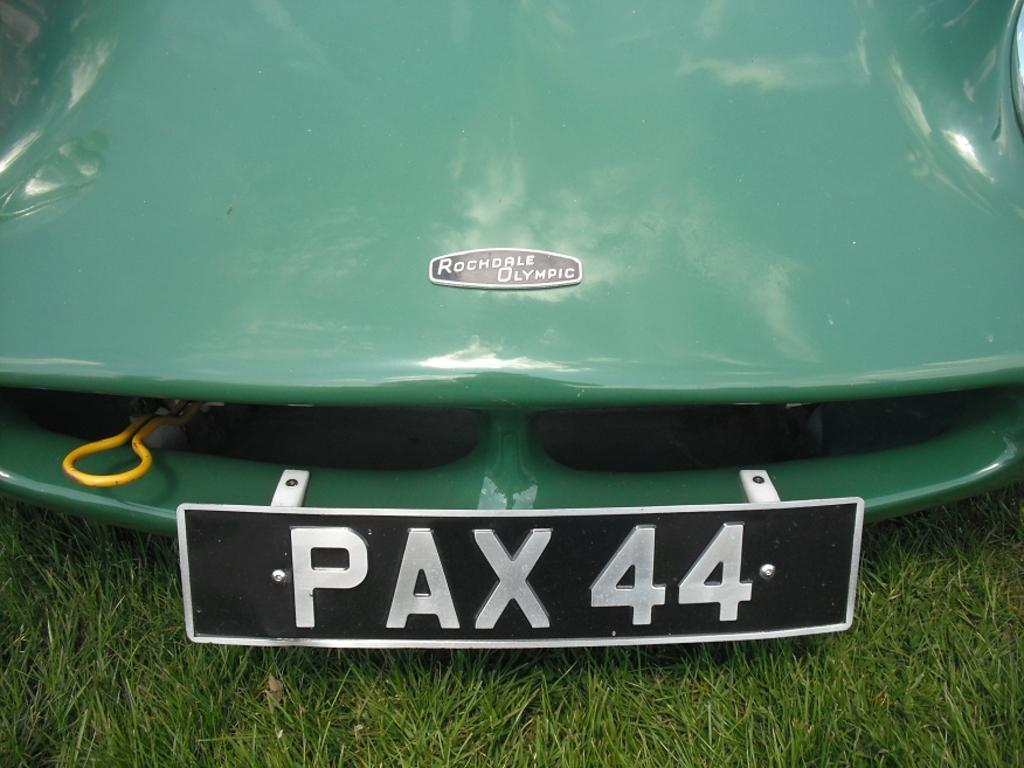Provide a one-sentence caption for the provided image. A front of a green car has a plate on front stating pax 44. 